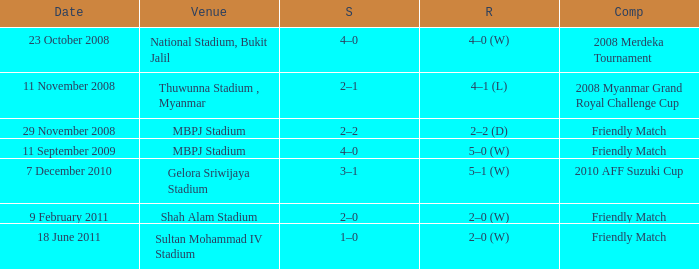What was the Score in Gelora Sriwijaya Stadium? 3–1. 